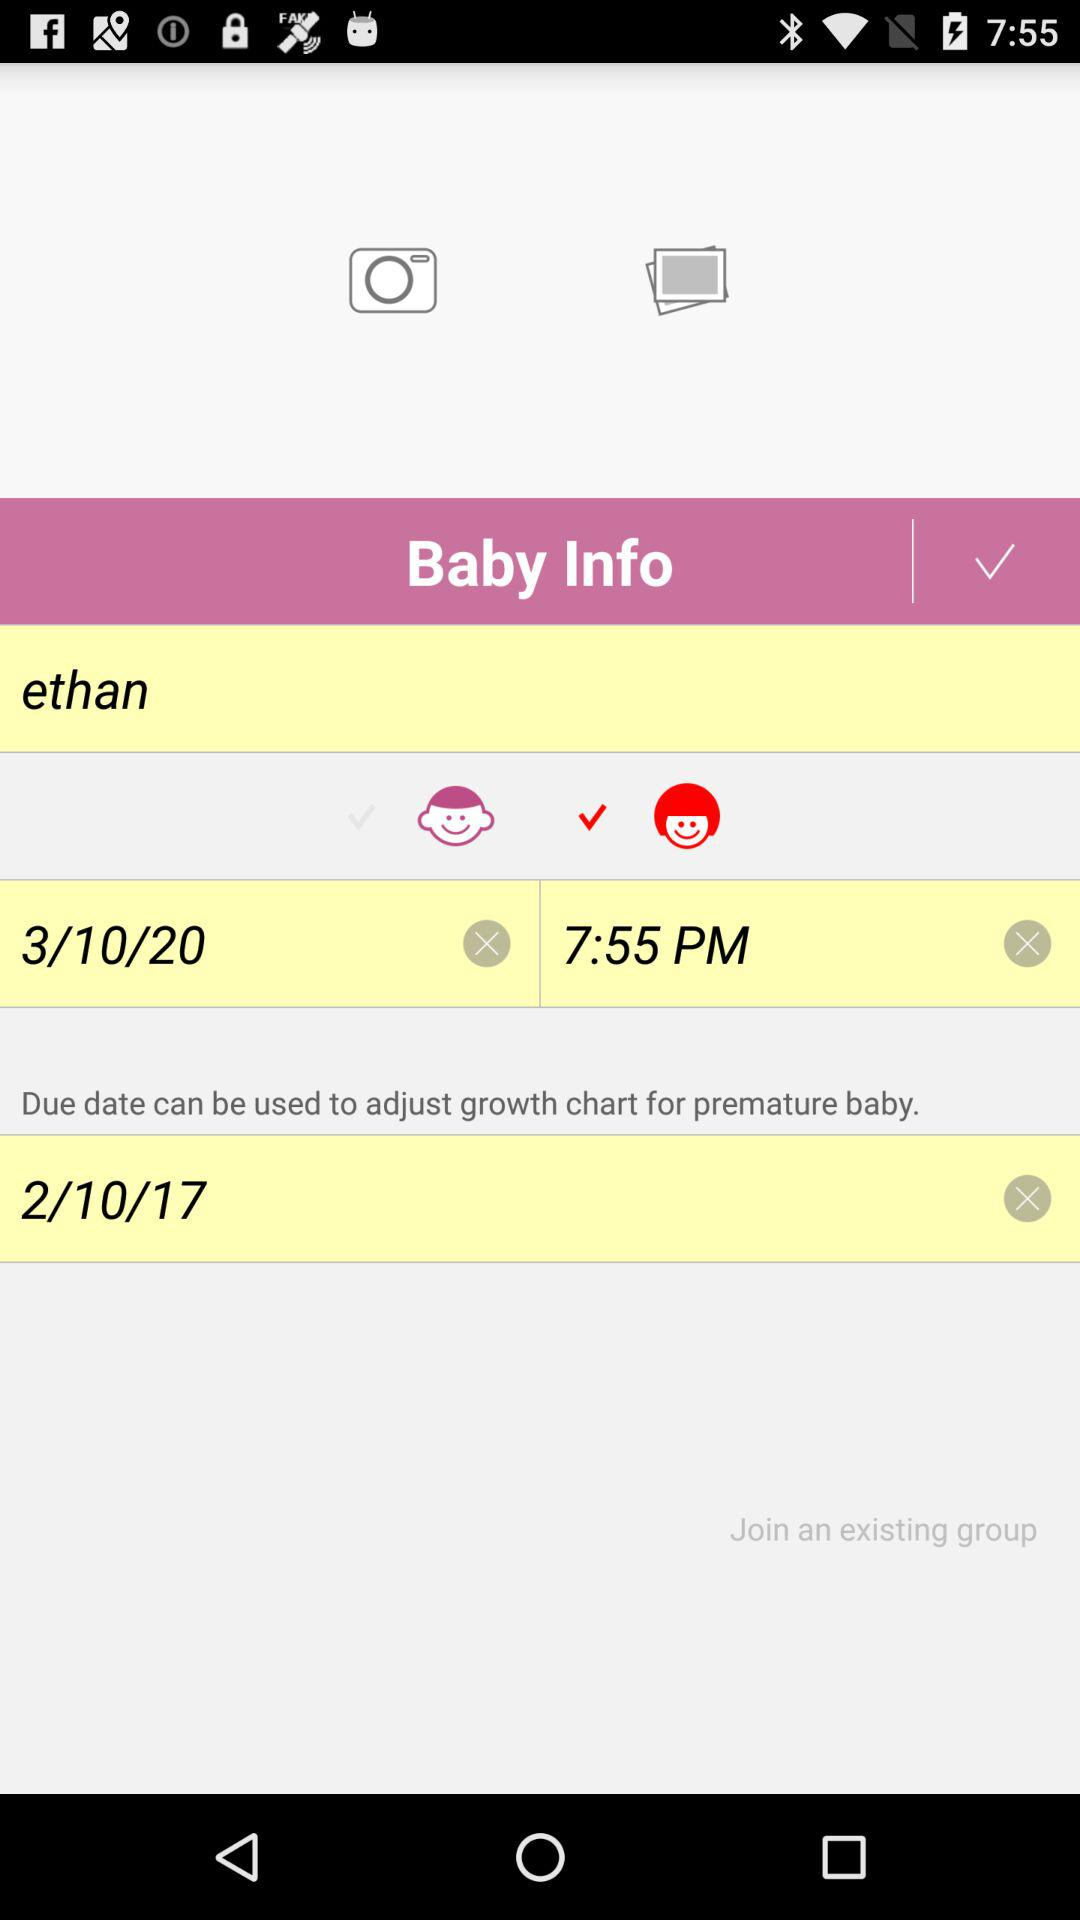What date is given to adjust the growth chart for premature baby? The given date is 2/10/17. 